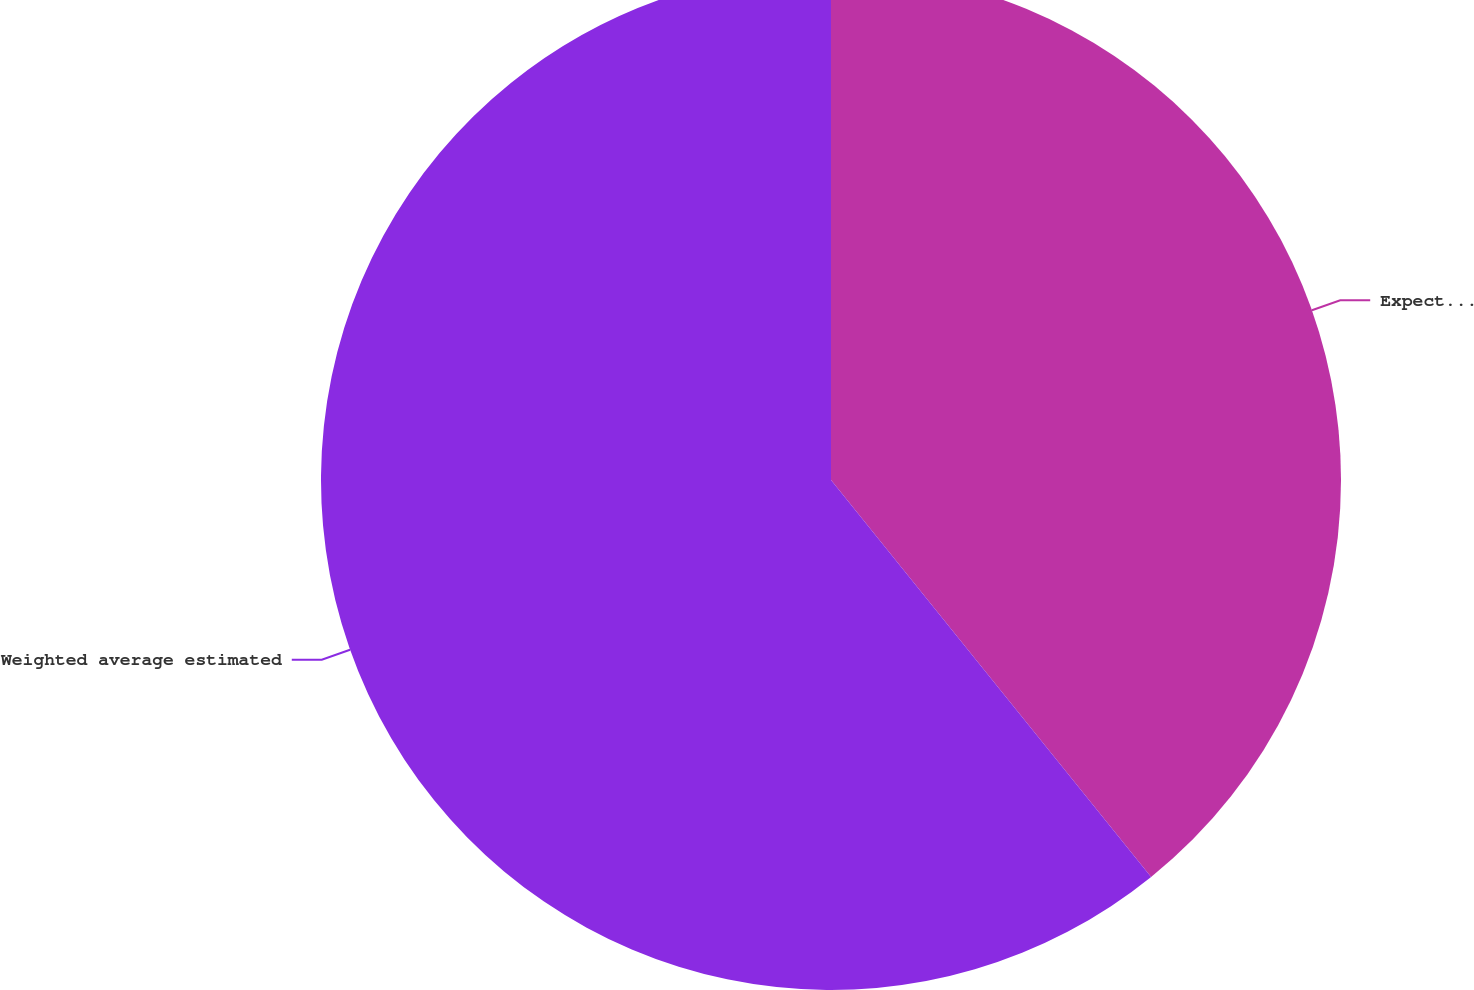Convert chart. <chart><loc_0><loc_0><loc_500><loc_500><pie_chart><fcel>Expected life (in years)<fcel>Weighted average estimated<nl><fcel>39.2%<fcel>60.8%<nl></chart> 